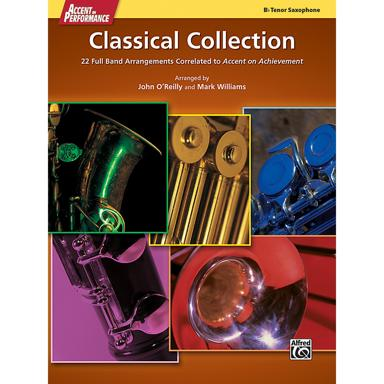What is the name of the classical collection mentioned in the image? The name of the classical collection mentioned in the image is "Tenor Saxophone Classical Collection." What is unique about this classical collection? This collection is unique because it includes 22 full band arrangements correlated to Accent on Achievement by John O'Reilly and Mark Williams. 